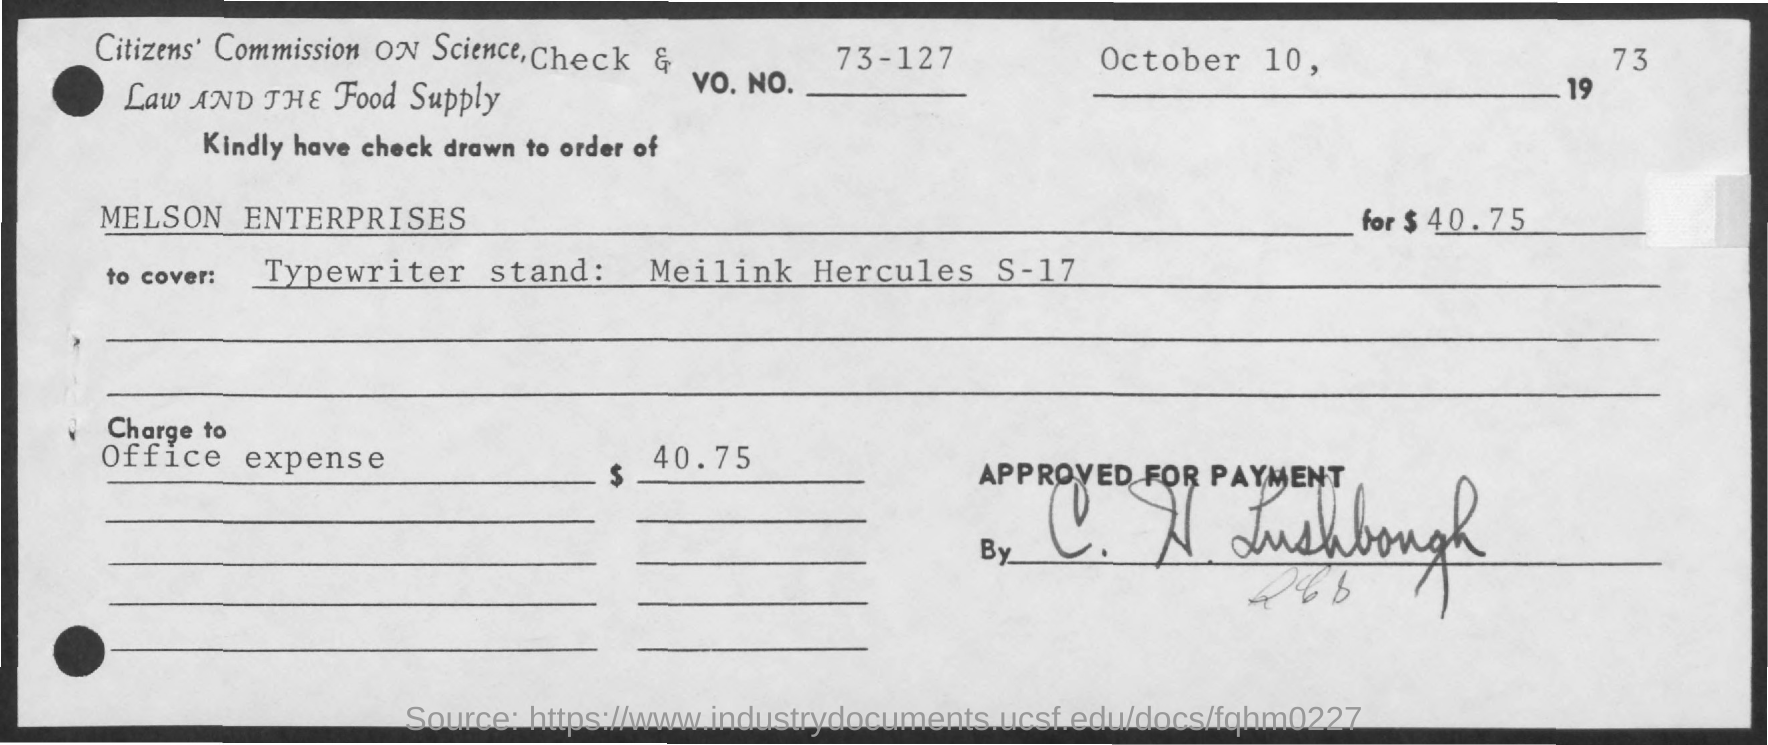Specify some key components in this picture. The date mentioned in the given form is October 10, 1973. The amount mentioned in the given form is $40.75. The number is 73-127. 